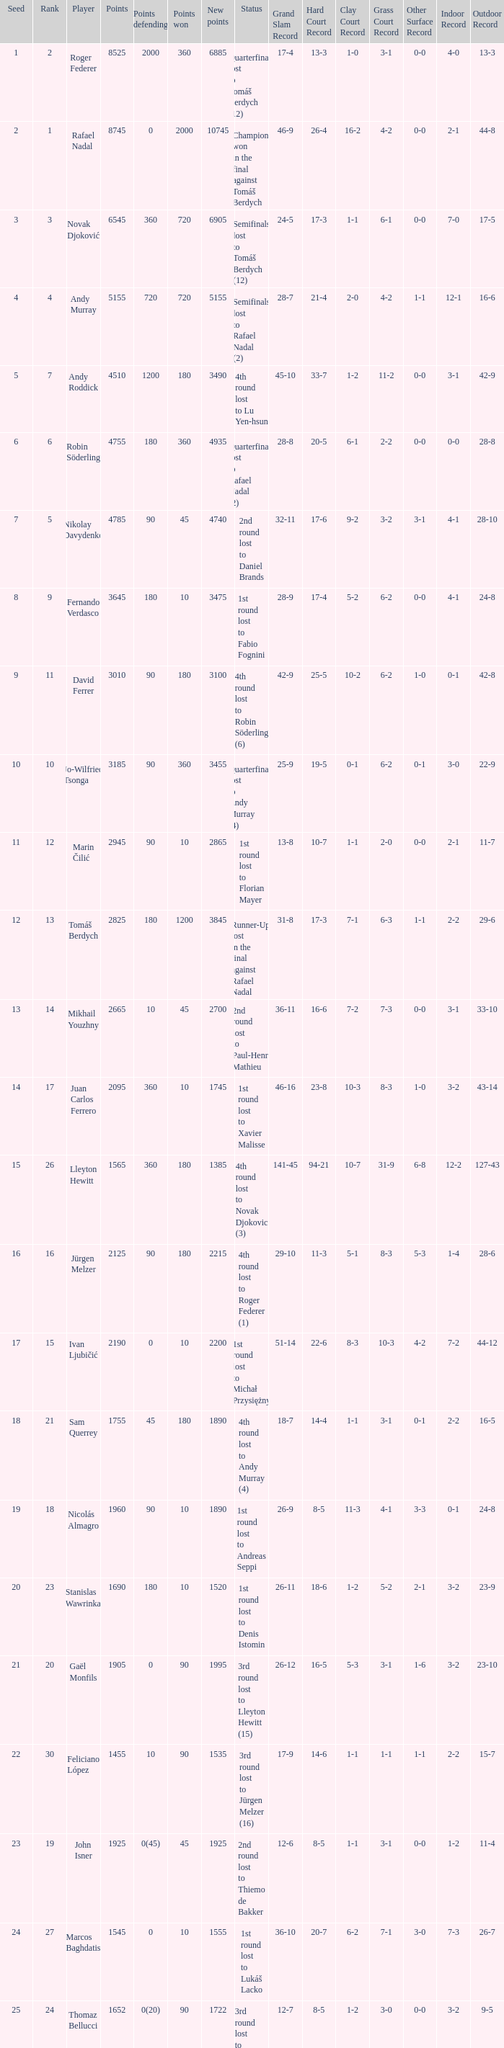Name the points won for 1230 90.0. 